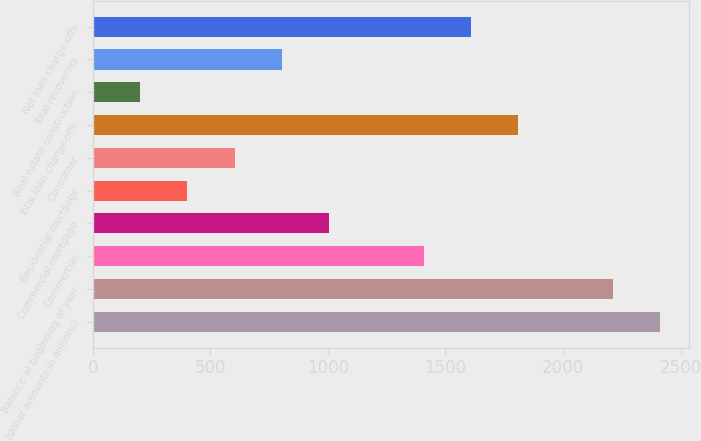Convert chart to OTSL. <chart><loc_0><loc_0><loc_500><loc_500><bar_chart><fcel>(dollar amounts in millions)<fcel>Balance at beginning of year<fcel>Commercial<fcel>Commercial mortgage<fcel>Residential mortgage<fcel>Consumer<fcel>Total loan charge-offs<fcel>Real estate construction<fcel>Total recoveries<fcel>Net loan charge-offs<nl><fcel>2413.06<fcel>2212.04<fcel>1407.96<fcel>1005.92<fcel>402.86<fcel>603.88<fcel>1810<fcel>201.84<fcel>804.9<fcel>1608.98<nl></chart> 